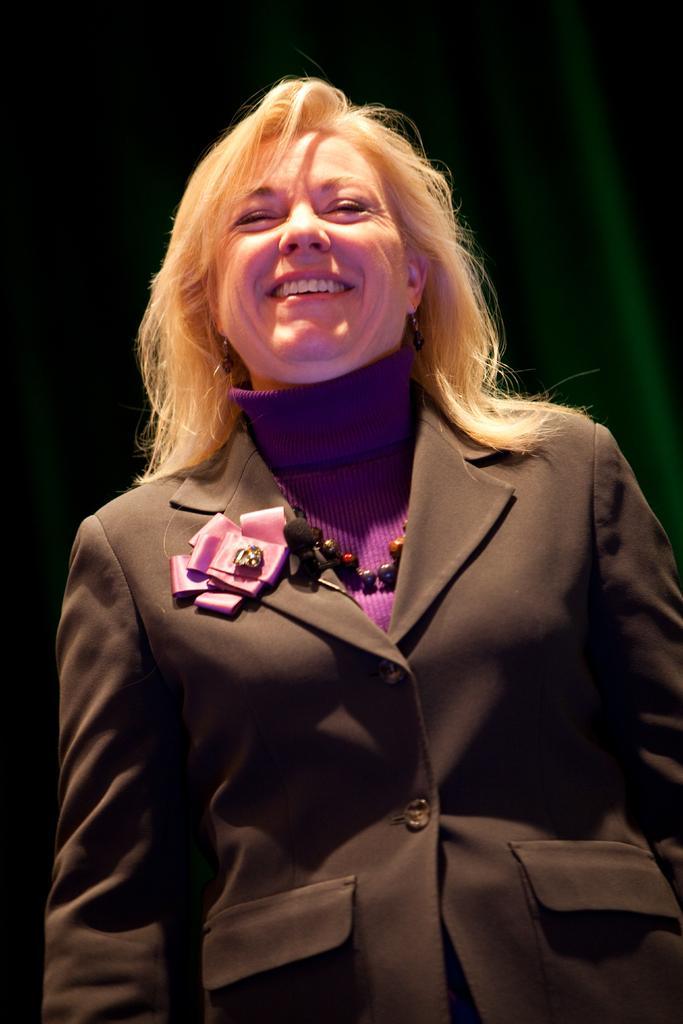Who is the main subject in the image? There is a woman in the image. Where is the woman located in the image? The woman is in the front of the image. What is the woman doing in the image? The woman is smiling. What is the woman wearing in the image? The woman is wearing a black blazer. What type of button can be seen on the woman's blazer in the image? There is no button visible on the woman's blazer in the image. How many stars are visible in the sky above the woman in the image? There is no sky visible in the image, and therefore no stars can be seen. 